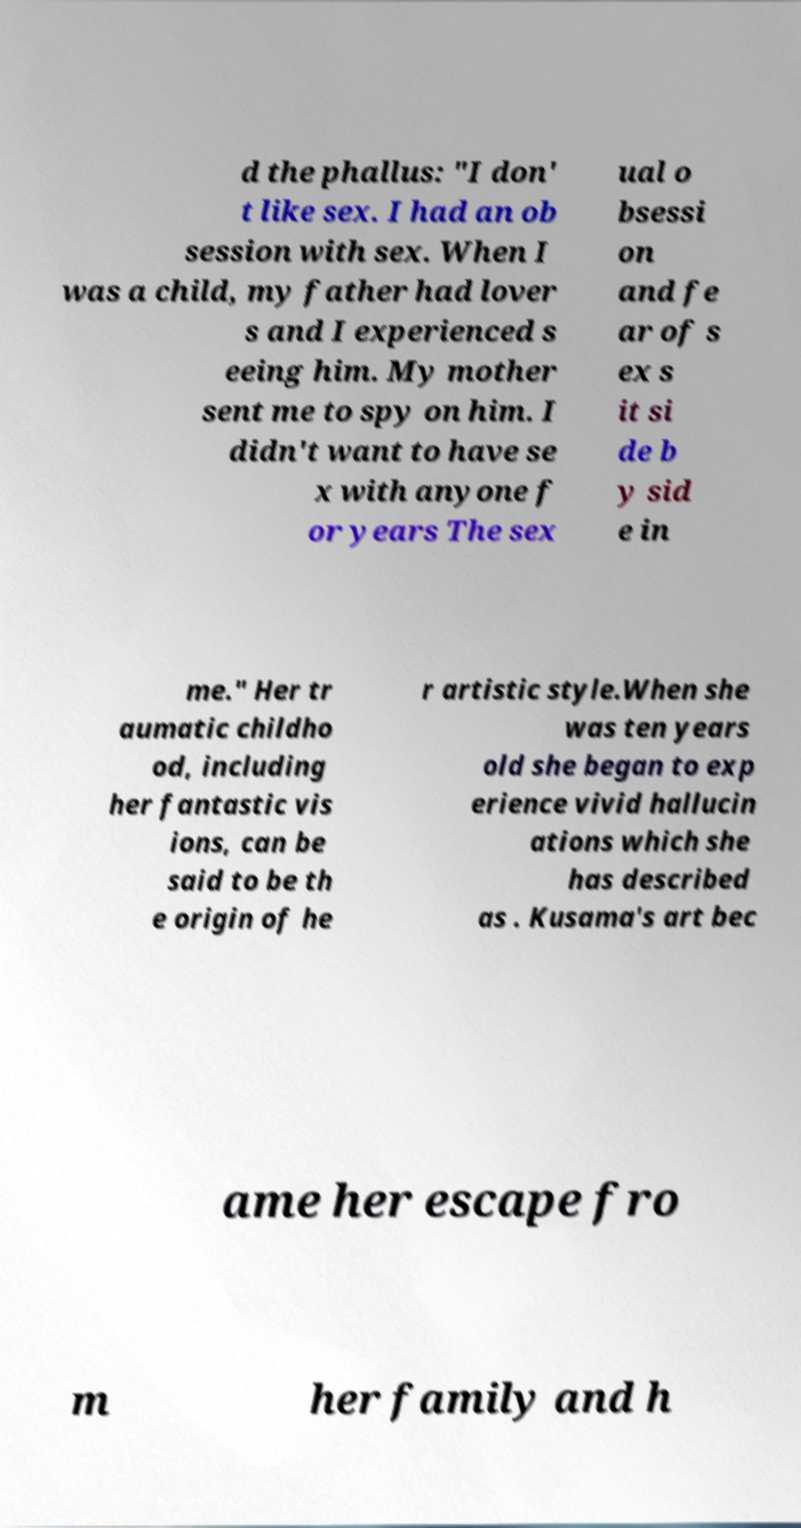Can you accurately transcribe the text from the provided image for me? d the phallus: "I don' t like sex. I had an ob session with sex. When I was a child, my father had lover s and I experienced s eeing him. My mother sent me to spy on him. I didn't want to have se x with anyone f or years The sex ual o bsessi on and fe ar of s ex s it si de b y sid e in me." Her tr aumatic childho od, including her fantastic vis ions, can be said to be th e origin of he r artistic style.When she was ten years old she began to exp erience vivid hallucin ations which she has described as . Kusama's art bec ame her escape fro m her family and h 